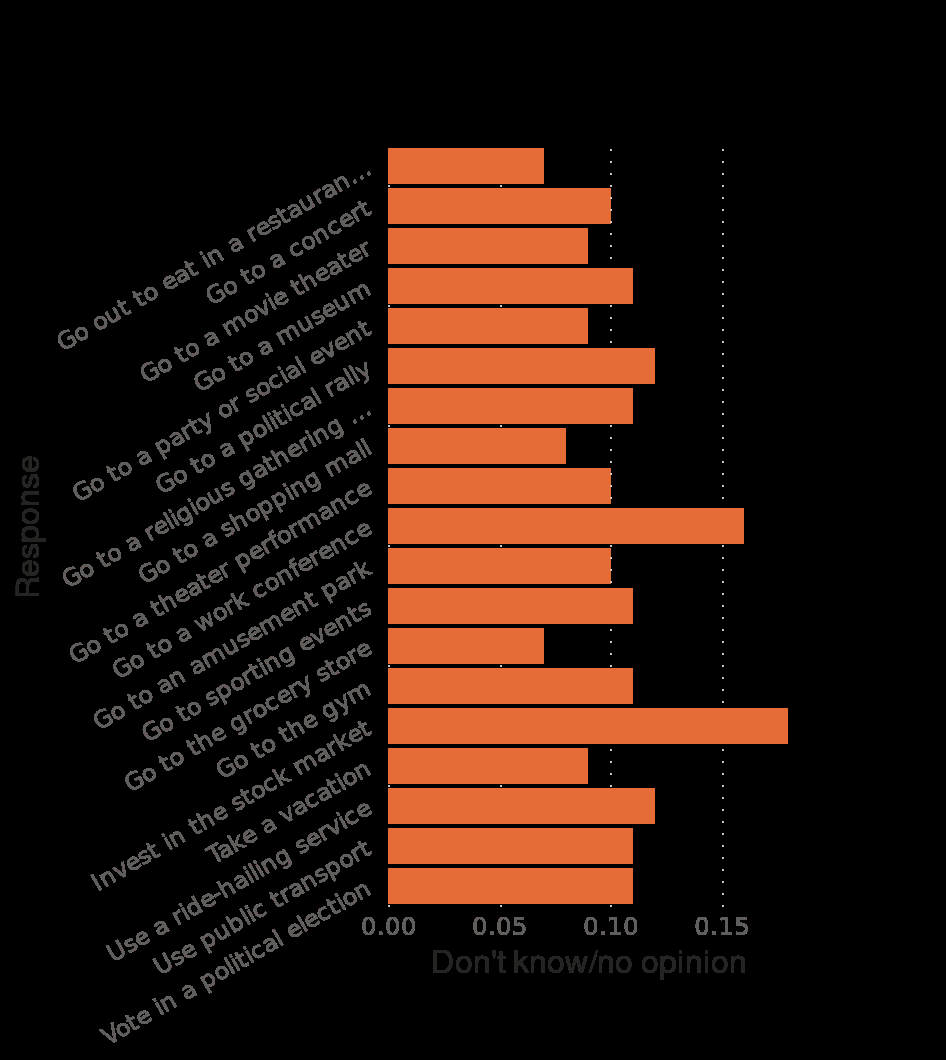<image>
What is the maximum scale value on the x-axis of the bar graph?  The maximum scale value on the x-axis of the bar graph is 0.15. please summary the statistics and relations of the chart the chart isnt laid out very well I understand the figures to read between 0.% and 0.15%   This is a very low percentage. This shows that very few people are prepared to change to the imminance of covid covid. What does the low percentage indicate? The low percentage indicates that very few people are prepared to change in response to the imminent threat of Covid-19. What is the minimum scale value on the x-axis of the bar graph?  The minimum scale value on the x-axis of the bar graph is 0.00. 